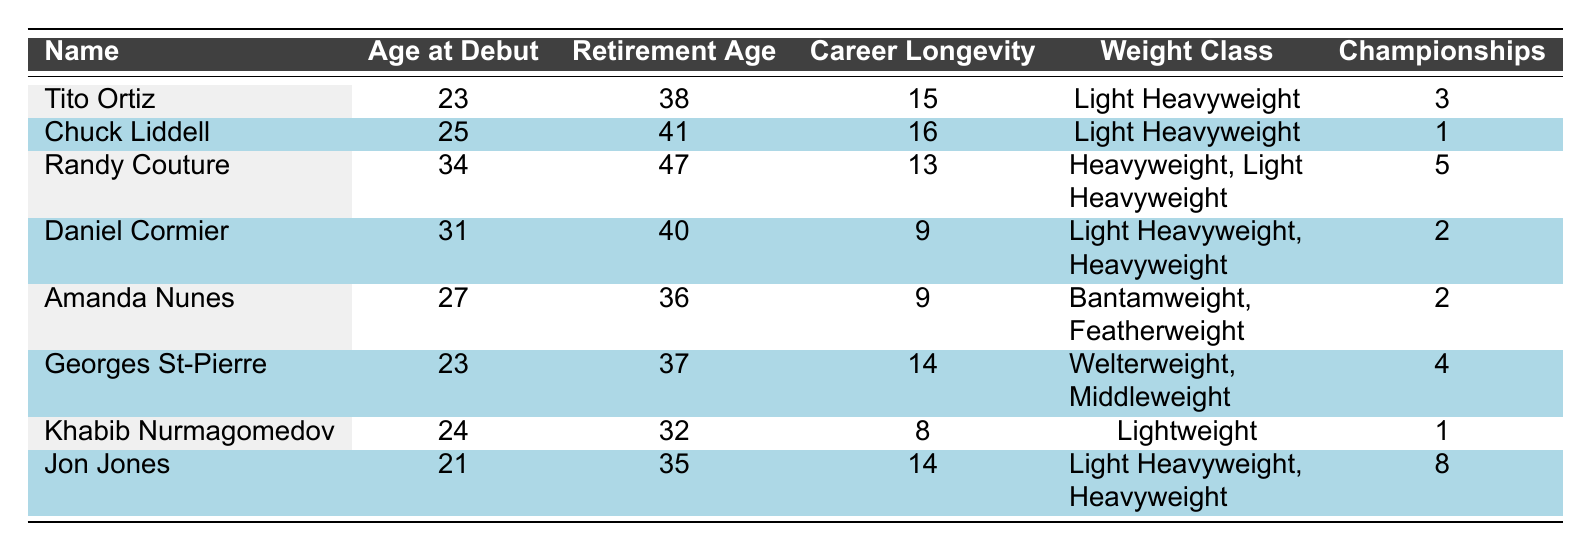What is the retirement age of Chuck Liddell? From the table, we can find Chuck Liddell's row which states that his retirement age is 41.
Answer: 41 What is the career longevity of Georges St-Pierre? By looking at the row for Georges St-Pierre, we see that his career longevity is 14 years.
Answer: 14 Who has the highest number of championships? By comparing the ‘Championships’ column for each champion, we see that Jon Jones has 8 championships, which is the highest.
Answer: Jon Jones Which fighters debuted at the age of 23? Referring to the table, the fighters who debuted at age 23 are Tito Ortiz and Georges St-Pierre.
Answer: Tito Ortiz and Georges St-Pierre What is the average age at debut of all the fighters listed? The age at debut values are 23, 25, 34, 31, 27, 23, 24, 21. Summing them gives 23 + 25 + 34 + 31 + 27 + 23 + 24 + 21 = 208, and there are 8 fighters. Thus, the average age at debut is 208/8 = 26.
Answer: 26 Did Amanda Nunes retire earlier than Daniel Cormier? From the retirement ages, Amanda Nunes retired at 36 while Daniel Cormier retired at 40. Since 36 < 40, the answer is yes.
Answer: Yes What is the combined career longevity of Randy Couture and Khabib Nurmagomedov? Randy Couture has a career longevity of 13 years, and Khabib Nurmagomedov has 8 years. Adding these gives 13 + 8 = 21.
Answer: 21 Are there any fighters with a career longevity of less than 10 years? The fighters with career longevity less than 10 years are Daniel Cormier (9), Amanda Nunes (9), and Khabib Nurmagomedov (8). Therefore, the answer is yes.
Answer: Yes What is the difference in retirement age between Jon Jones and Tito Ortiz? The retirement age of Jon Jones is 35 and for Tito Ortiz, it is 38. The difference is 38 - 35 = 3.
Answer: 3 